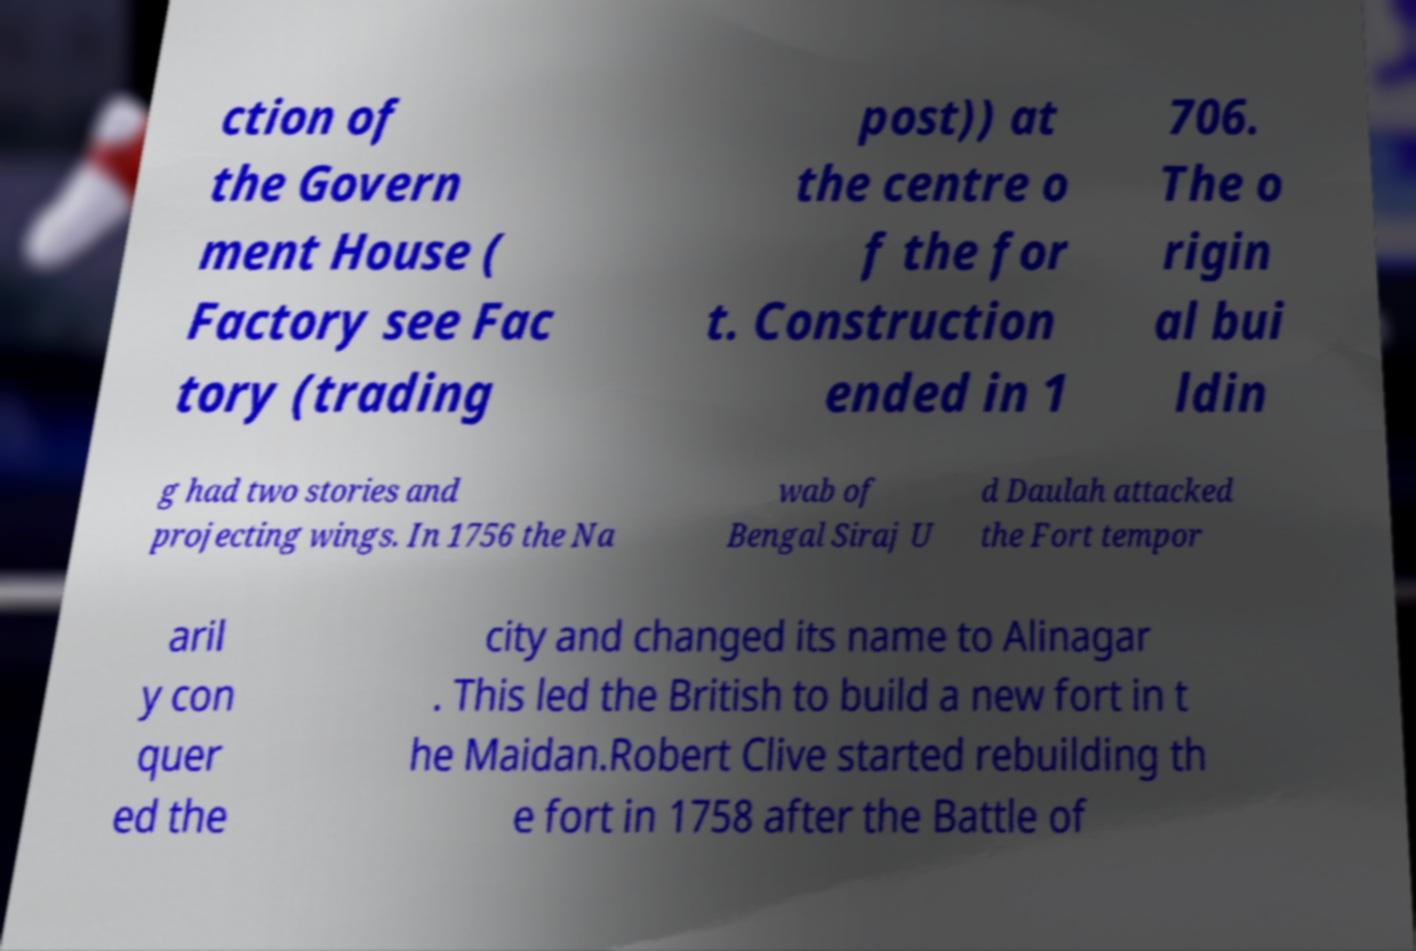Please read and relay the text visible in this image. What does it say? ction of the Govern ment House ( Factory see Fac tory (trading post)) at the centre o f the for t. Construction ended in 1 706. The o rigin al bui ldin g had two stories and projecting wings. In 1756 the Na wab of Bengal Siraj U d Daulah attacked the Fort tempor aril y con quer ed the city and changed its name to Alinagar . This led the British to build a new fort in t he Maidan.Robert Clive started rebuilding th e fort in 1758 after the Battle of 